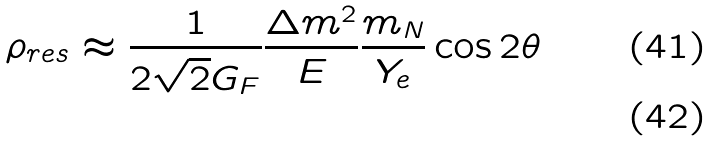Convert formula to latex. <formula><loc_0><loc_0><loc_500><loc_500>\rho _ { r e s } \approx \frac { 1 } { 2 \sqrt { 2 } G _ { F } } \frac { \Delta m ^ { 2 } } { E } \frac { m _ { N } } { Y _ { e } } \cos 2 \theta \\</formula> 